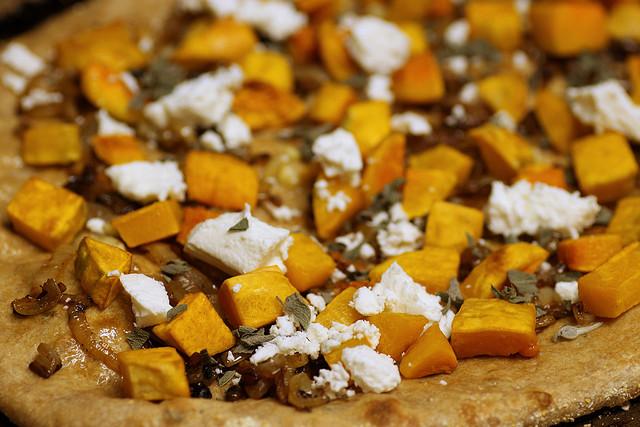Is there any dairy in the image?
Short answer required. Yes. What texture are the white objects?
Short answer required. Crumbly. Is that bird food?
Be succinct. No. 